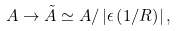Convert formula to latex. <formula><loc_0><loc_0><loc_500><loc_500>A \rightarrow \tilde { A } \simeq A / \left | \epsilon \left ( 1 / R \right ) \right | ,</formula> 